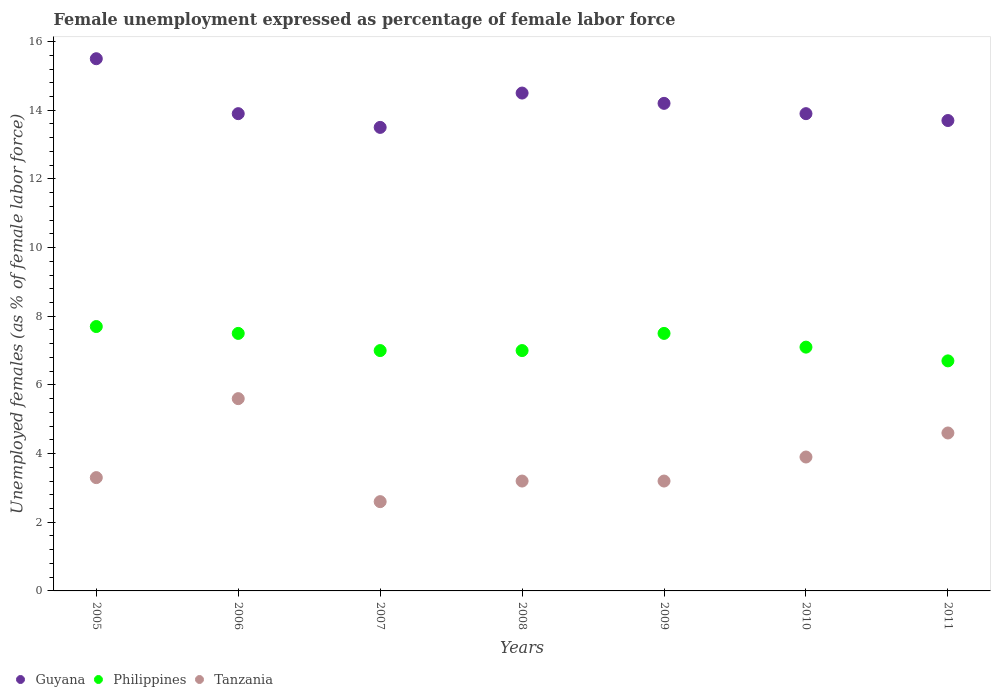How many different coloured dotlines are there?
Keep it short and to the point. 3. What is the unemployment in females in in Guyana in 2010?
Your response must be concise. 13.9. Across all years, what is the maximum unemployment in females in in Guyana?
Your answer should be very brief. 15.5. Across all years, what is the minimum unemployment in females in in Philippines?
Provide a short and direct response. 6.7. In which year was the unemployment in females in in Philippines maximum?
Your answer should be compact. 2005. In which year was the unemployment in females in in Tanzania minimum?
Provide a succinct answer. 2007. What is the total unemployment in females in in Guyana in the graph?
Your response must be concise. 99.2. What is the difference between the unemployment in females in in Guyana in 2009 and that in 2011?
Offer a very short reply. 0.5. What is the difference between the unemployment in females in in Tanzania in 2006 and the unemployment in females in in Philippines in 2008?
Your answer should be compact. -1.4. What is the average unemployment in females in in Philippines per year?
Keep it short and to the point. 7.21. In the year 2008, what is the difference between the unemployment in females in in Philippines and unemployment in females in in Guyana?
Provide a succinct answer. -7.5. In how many years, is the unemployment in females in in Guyana greater than 8 %?
Ensure brevity in your answer.  7. What is the ratio of the unemployment in females in in Guyana in 2008 to that in 2011?
Make the answer very short. 1.06. Is the unemployment in females in in Tanzania in 2005 less than that in 2007?
Provide a short and direct response. No. Is the difference between the unemployment in females in in Philippines in 2005 and 2009 greater than the difference between the unemployment in females in in Guyana in 2005 and 2009?
Your answer should be very brief. No. What is the difference between the highest and the second highest unemployment in females in in Tanzania?
Offer a terse response. 1. What is the difference between the highest and the lowest unemployment in females in in Philippines?
Provide a short and direct response. 1. Is it the case that in every year, the sum of the unemployment in females in in Tanzania and unemployment in females in in Philippines  is greater than the unemployment in females in in Guyana?
Make the answer very short. No. Is the unemployment in females in in Guyana strictly greater than the unemployment in females in in Philippines over the years?
Offer a terse response. Yes. Is the unemployment in females in in Philippines strictly less than the unemployment in females in in Guyana over the years?
Offer a very short reply. Yes. How many dotlines are there?
Offer a terse response. 3. How many years are there in the graph?
Your response must be concise. 7. How many legend labels are there?
Ensure brevity in your answer.  3. How are the legend labels stacked?
Offer a terse response. Horizontal. What is the title of the graph?
Your answer should be very brief. Female unemployment expressed as percentage of female labor force. Does "Madagascar" appear as one of the legend labels in the graph?
Offer a terse response. No. What is the label or title of the X-axis?
Provide a succinct answer. Years. What is the label or title of the Y-axis?
Keep it short and to the point. Unemployed females (as % of female labor force). What is the Unemployed females (as % of female labor force) in Philippines in 2005?
Keep it short and to the point. 7.7. What is the Unemployed females (as % of female labor force) in Tanzania in 2005?
Provide a succinct answer. 3.3. What is the Unemployed females (as % of female labor force) in Guyana in 2006?
Provide a succinct answer. 13.9. What is the Unemployed females (as % of female labor force) in Philippines in 2006?
Your response must be concise. 7.5. What is the Unemployed females (as % of female labor force) in Tanzania in 2006?
Keep it short and to the point. 5.6. What is the Unemployed females (as % of female labor force) of Guyana in 2007?
Provide a succinct answer. 13.5. What is the Unemployed females (as % of female labor force) of Tanzania in 2007?
Give a very brief answer. 2.6. What is the Unemployed females (as % of female labor force) in Philippines in 2008?
Keep it short and to the point. 7. What is the Unemployed females (as % of female labor force) of Tanzania in 2008?
Your response must be concise. 3.2. What is the Unemployed females (as % of female labor force) of Guyana in 2009?
Your response must be concise. 14.2. What is the Unemployed females (as % of female labor force) in Tanzania in 2009?
Give a very brief answer. 3.2. What is the Unemployed females (as % of female labor force) in Guyana in 2010?
Offer a terse response. 13.9. What is the Unemployed females (as % of female labor force) of Philippines in 2010?
Make the answer very short. 7.1. What is the Unemployed females (as % of female labor force) in Tanzania in 2010?
Offer a very short reply. 3.9. What is the Unemployed females (as % of female labor force) of Guyana in 2011?
Your answer should be compact. 13.7. What is the Unemployed females (as % of female labor force) of Philippines in 2011?
Offer a very short reply. 6.7. What is the Unemployed females (as % of female labor force) of Tanzania in 2011?
Keep it short and to the point. 4.6. Across all years, what is the maximum Unemployed females (as % of female labor force) of Guyana?
Give a very brief answer. 15.5. Across all years, what is the maximum Unemployed females (as % of female labor force) in Philippines?
Make the answer very short. 7.7. Across all years, what is the maximum Unemployed females (as % of female labor force) in Tanzania?
Your answer should be compact. 5.6. Across all years, what is the minimum Unemployed females (as % of female labor force) in Guyana?
Your response must be concise. 13.5. Across all years, what is the minimum Unemployed females (as % of female labor force) of Philippines?
Make the answer very short. 6.7. Across all years, what is the minimum Unemployed females (as % of female labor force) of Tanzania?
Ensure brevity in your answer.  2.6. What is the total Unemployed females (as % of female labor force) of Guyana in the graph?
Give a very brief answer. 99.2. What is the total Unemployed females (as % of female labor force) of Philippines in the graph?
Ensure brevity in your answer.  50.5. What is the total Unemployed females (as % of female labor force) in Tanzania in the graph?
Your answer should be very brief. 26.4. What is the difference between the Unemployed females (as % of female labor force) of Guyana in 2005 and that in 2006?
Provide a short and direct response. 1.6. What is the difference between the Unemployed females (as % of female labor force) of Philippines in 2005 and that in 2007?
Make the answer very short. 0.7. What is the difference between the Unemployed females (as % of female labor force) of Tanzania in 2005 and that in 2008?
Offer a terse response. 0.1. What is the difference between the Unemployed females (as % of female labor force) of Philippines in 2005 and that in 2009?
Provide a succinct answer. 0.2. What is the difference between the Unemployed females (as % of female labor force) in Guyana in 2005 and that in 2010?
Provide a succinct answer. 1.6. What is the difference between the Unemployed females (as % of female labor force) of Tanzania in 2005 and that in 2010?
Offer a very short reply. -0.6. What is the difference between the Unemployed females (as % of female labor force) in Guyana in 2005 and that in 2011?
Ensure brevity in your answer.  1.8. What is the difference between the Unemployed females (as % of female labor force) in Philippines in 2005 and that in 2011?
Your answer should be very brief. 1. What is the difference between the Unemployed females (as % of female labor force) of Tanzania in 2005 and that in 2011?
Your answer should be compact. -1.3. What is the difference between the Unemployed females (as % of female labor force) of Guyana in 2006 and that in 2007?
Your answer should be very brief. 0.4. What is the difference between the Unemployed females (as % of female labor force) of Philippines in 2006 and that in 2007?
Your answer should be compact. 0.5. What is the difference between the Unemployed females (as % of female labor force) of Philippines in 2006 and that in 2008?
Ensure brevity in your answer.  0.5. What is the difference between the Unemployed females (as % of female labor force) of Guyana in 2006 and that in 2009?
Your answer should be compact. -0.3. What is the difference between the Unemployed females (as % of female labor force) of Philippines in 2006 and that in 2009?
Your answer should be compact. 0. What is the difference between the Unemployed females (as % of female labor force) in Guyana in 2006 and that in 2010?
Give a very brief answer. 0. What is the difference between the Unemployed females (as % of female labor force) of Philippines in 2006 and that in 2010?
Give a very brief answer. 0.4. What is the difference between the Unemployed females (as % of female labor force) in Guyana in 2006 and that in 2011?
Your response must be concise. 0.2. What is the difference between the Unemployed females (as % of female labor force) in Philippines in 2006 and that in 2011?
Provide a short and direct response. 0.8. What is the difference between the Unemployed females (as % of female labor force) in Guyana in 2007 and that in 2008?
Your answer should be very brief. -1. What is the difference between the Unemployed females (as % of female labor force) of Tanzania in 2007 and that in 2008?
Your answer should be very brief. -0.6. What is the difference between the Unemployed females (as % of female labor force) of Philippines in 2007 and that in 2009?
Keep it short and to the point. -0.5. What is the difference between the Unemployed females (as % of female labor force) of Guyana in 2007 and that in 2010?
Your response must be concise. -0.4. What is the difference between the Unemployed females (as % of female labor force) of Tanzania in 2007 and that in 2010?
Your answer should be compact. -1.3. What is the difference between the Unemployed females (as % of female labor force) in Philippines in 2007 and that in 2011?
Make the answer very short. 0.3. What is the difference between the Unemployed females (as % of female labor force) in Tanzania in 2007 and that in 2011?
Keep it short and to the point. -2. What is the difference between the Unemployed females (as % of female labor force) in Guyana in 2008 and that in 2009?
Ensure brevity in your answer.  0.3. What is the difference between the Unemployed females (as % of female labor force) in Philippines in 2008 and that in 2009?
Provide a succinct answer. -0.5. What is the difference between the Unemployed females (as % of female labor force) in Tanzania in 2008 and that in 2009?
Your answer should be compact. 0. What is the difference between the Unemployed females (as % of female labor force) of Guyana in 2008 and that in 2010?
Make the answer very short. 0.6. What is the difference between the Unemployed females (as % of female labor force) in Philippines in 2008 and that in 2010?
Your answer should be very brief. -0.1. What is the difference between the Unemployed females (as % of female labor force) in Tanzania in 2008 and that in 2010?
Make the answer very short. -0.7. What is the difference between the Unemployed females (as % of female labor force) of Guyana in 2008 and that in 2011?
Offer a terse response. 0.8. What is the difference between the Unemployed females (as % of female labor force) in Philippines in 2009 and that in 2010?
Give a very brief answer. 0.4. What is the difference between the Unemployed females (as % of female labor force) of Philippines in 2009 and that in 2011?
Your response must be concise. 0.8. What is the difference between the Unemployed females (as % of female labor force) of Tanzania in 2009 and that in 2011?
Offer a very short reply. -1.4. What is the difference between the Unemployed females (as % of female labor force) of Guyana in 2010 and that in 2011?
Offer a very short reply. 0.2. What is the difference between the Unemployed females (as % of female labor force) of Tanzania in 2010 and that in 2011?
Make the answer very short. -0.7. What is the difference between the Unemployed females (as % of female labor force) in Philippines in 2005 and the Unemployed females (as % of female labor force) in Tanzania in 2006?
Provide a short and direct response. 2.1. What is the difference between the Unemployed females (as % of female labor force) in Guyana in 2005 and the Unemployed females (as % of female labor force) in Philippines in 2007?
Your answer should be very brief. 8.5. What is the difference between the Unemployed females (as % of female labor force) of Guyana in 2005 and the Unemployed females (as % of female labor force) of Tanzania in 2007?
Offer a very short reply. 12.9. What is the difference between the Unemployed females (as % of female labor force) of Philippines in 2005 and the Unemployed females (as % of female labor force) of Tanzania in 2007?
Your response must be concise. 5.1. What is the difference between the Unemployed females (as % of female labor force) of Guyana in 2005 and the Unemployed females (as % of female labor force) of Philippines in 2008?
Keep it short and to the point. 8.5. What is the difference between the Unemployed females (as % of female labor force) in Guyana in 2005 and the Unemployed females (as % of female labor force) in Philippines in 2009?
Give a very brief answer. 8. What is the difference between the Unemployed females (as % of female labor force) in Guyana in 2005 and the Unemployed females (as % of female labor force) in Tanzania in 2009?
Your answer should be very brief. 12.3. What is the difference between the Unemployed females (as % of female labor force) in Philippines in 2005 and the Unemployed females (as % of female labor force) in Tanzania in 2009?
Offer a terse response. 4.5. What is the difference between the Unemployed females (as % of female labor force) in Guyana in 2005 and the Unemployed females (as % of female labor force) in Philippines in 2010?
Provide a short and direct response. 8.4. What is the difference between the Unemployed females (as % of female labor force) in Guyana in 2006 and the Unemployed females (as % of female labor force) in Philippines in 2007?
Offer a terse response. 6.9. What is the difference between the Unemployed females (as % of female labor force) in Guyana in 2006 and the Unemployed females (as % of female labor force) in Tanzania in 2007?
Make the answer very short. 11.3. What is the difference between the Unemployed females (as % of female labor force) in Guyana in 2006 and the Unemployed females (as % of female labor force) in Tanzania in 2008?
Your answer should be compact. 10.7. What is the difference between the Unemployed females (as % of female labor force) in Philippines in 2006 and the Unemployed females (as % of female labor force) in Tanzania in 2008?
Your answer should be very brief. 4.3. What is the difference between the Unemployed females (as % of female labor force) of Guyana in 2006 and the Unemployed females (as % of female labor force) of Philippines in 2009?
Ensure brevity in your answer.  6.4. What is the difference between the Unemployed females (as % of female labor force) of Guyana in 2006 and the Unemployed females (as % of female labor force) of Tanzania in 2009?
Give a very brief answer. 10.7. What is the difference between the Unemployed females (as % of female labor force) of Guyana in 2006 and the Unemployed females (as % of female labor force) of Philippines in 2010?
Your answer should be compact. 6.8. What is the difference between the Unemployed females (as % of female labor force) in Guyana in 2006 and the Unemployed females (as % of female labor force) in Tanzania in 2010?
Make the answer very short. 10. What is the difference between the Unemployed females (as % of female labor force) of Philippines in 2006 and the Unemployed females (as % of female labor force) of Tanzania in 2010?
Offer a very short reply. 3.6. What is the difference between the Unemployed females (as % of female labor force) in Guyana in 2006 and the Unemployed females (as % of female labor force) in Tanzania in 2011?
Ensure brevity in your answer.  9.3. What is the difference between the Unemployed females (as % of female labor force) in Guyana in 2007 and the Unemployed females (as % of female labor force) in Philippines in 2008?
Provide a succinct answer. 6.5. What is the difference between the Unemployed females (as % of female labor force) in Guyana in 2007 and the Unemployed females (as % of female labor force) in Tanzania in 2008?
Ensure brevity in your answer.  10.3. What is the difference between the Unemployed females (as % of female labor force) of Philippines in 2007 and the Unemployed females (as % of female labor force) of Tanzania in 2008?
Make the answer very short. 3.8. What is the difference between the Unemployed females (as % of female labor force) in Guyana in 2007 and the Unemployed females (as % of female labor force) in Tanzania in 2009?
Provide a succinct answer. 10.3. What is the difference between the Unemployed females (as % of female labor force) in Philippines in 2007 and the Unemployed females (as % of female labor force) in Tanzania in 2009?
Provide a succinct answer. 3.8. What is the difference between the Unemployed females (as % of female labor force) of Guyana in 2007 and the Unemployed females (as % of female labor force) of Tanzania in 2011?
Your answer should be very brief. 8.9. What is the difference between the Unemployed females (as % of female labor force) of Guyana in 2008 and the Unemployed females (as % of female labor force) of Tanzania in 2009?
Keep it short and to the point. 11.3. What is the difference between the Unemployed females (as % of female labor force) in Philippines in 2008 and the Unemployed females (as % of female labor force) in Tanzania in 2009?
Offer a very short reply. 3.8. What is the difference between the Unemployed females (as % of female labor force) in Philippines in 2008 and the Unemployed females (as % of female labor force) in Tanzania in 2010?
Give a very brief answer. 3.1. What is the difference between the Unemployed females (as % of female labor force) in Philippines in 2008 and the Unemployed females (as % of female labor force) in Tanzania in 2011?
Give a very brief answer. 2.4. What is the difference between the Unemployed females (as % of female labor force) of Guyana in 2009 and the Unemployed females (as % of female labor force) of Tanzania in 2010?
Offer a very short reply. 10.3. What is the difference between the Unemployed females (as % of female labor force) in Philippines in 2009 and the Unemployed females (as % of female labor force) in Tanzania in 2010?
Provide a short and direct response. 3.6. What is the difference between the Unemployed females (as % of female labor force) of Guyana in 2009 and the Unemployed females (as % of female labor force) of Philippines in 2011?
Give a very brief answer. 7.5. What is the difference between the Unemployed females (as % of female labor force) in Guyana in 2009 and the Unemployed females (as % of female labor force) in Tanzania in 2011?
Provide a short and direct response. 9.6. What is the difference between the Unemployed females (as % of female labor force) of Philippines in 2009 and the Unemployed females (as % of female labor force) of Tanzania in 2011?
Provide a succinct answer. 2.9. What is the average Unemployed females (as % of female labor force) in Guyana per year?
Make the answer very short. 14.17. What is the average Unemployed females (as % of female labor force) of Philippines per year?
Make the answer very short. 7.21. What is the average Unemployed females (as % of female labor force) in Tanzania per year?
Give a very brief answer. 3.77. In the year 2005, what is the difference between the Unemployed females (as % of female labor force) in Guyana and Unemployed females (as % of female labor force) in Philippines?
Your answer should be very brief. 7.8. In the year 2007, what is the difference between the Unemployed females (as % of female labor force) of Guyana and Unemployed females (as % of female labor force) of Philippines?
Provide a succinct answer. 6.5. In the year 2008, what is the difference between the Unemployed females (as % of female labor force) of Guyana and Unemployed females (as % of female labor force) of Philippines?
Provide a succinct answer. 7.5. In the year 2008, what is the difference between the Unemployed females (as % of female labor force) of Guyana and Unemployed females (as % of female labor force) of Tanzania?
Give a very brief answer. 11.3. In the year 2008, what is the difference between the Unemployed females (as % of female labor force) of Philippines and Unemployed females (as % of female labor force) of Tanzania?
Your answer should be compact. 3.8. In the year 2009, what is the difference between the Unemployed females (as % of female labor force) in Guyana and Unemployed females (as % of female labor force) in Tanzania?
Provide a short and direct response. 11. In the year 2010, what is the difference between the Unemployed females (as % of female labor force) in Guyana and Unemployed females (as % of female labor force) in Tanzania?
Keep it short and to the point. 10. In the year 2010, what is the difference between the Unemployed females (as % of female labor force) of Philippines and Unemployed females (as % of female labor force) of Tanzania?
Keep it short and to the point. 3.2. In the year 2011, what is the difference between the Unemployed females (as % of female labor force) in Guyana and Unemployed females (as % of female labor force) in Philippines?
Your answer should be compact. 7. What is the ratio of the Unemployed females (as % of female labor force) of Guyana in 2005 to that in 2006?
Offer a terse response. 1.12. What is the ratio of the Unemployed females (as % of female labor force) of Philippines in 2005 to that in 2006?
Your answer should be compact. 1.03. What is the ratio of the Unemployed females (as % of female labor force) in Tanzania in 2005 to that in 2006?
Keep it short and to the point. 0.59. What is the ratio of the Unemployed females (as % of female labor force) in Guyana in 2005 to that in 2007?
Provide a succinct answer. 1.15. What is the ratio of the Unemployed females (as % of female labor force) in Tanzania in 2005 to that in 2007?
Provide a succinct answer. 1.27. What is the ratio of the Unemployed females (as % of female labor force) in Guyana in 2005 to that in 2008?
Give a very brief answer. 1.07. What is the ratio of the Unemployed females (as % of female labor force) in Philippines in 2005 to that in 2008?
Provide a succinct answer. 1.1. What is the ratio of the Unemployed females (as % of female labor force) of Tanzania in 2005 to that in 2008?
Provide a succinct answer. 1.03. What is the ratio of the Unemployed females (as % of female labor force) in Guyana in 2005 to that in 2009?
Offer a very short reply. 1.09. What is the ratio of the Unemployed females (as % of female labor force) in Philippines in 2005 to that in 2009?
Your answer should be compact. 1.03. What is the ratio of the Unemployed females (as % of female labor force) of Tanzania in 2005 to that in 2009?
Your response must be concise. 1.03. What is the ratio of the Unemployed females (as % of female labor force) in Guyana in 2005 to that in 2010?
Give a very brief answer. 1.12. What is the ratio of the Unemployed females (as % of female labor force) in Philippines in 2005 to that in 2010?
Provide a succinct answer. 1.08. What is the ratio of the Unemployed females (as % of female labor force) in Tanzania in 2005 to that in 2010?
Your answer should be compact. 0.85. What is the ratio of the Unemployed females (as % of female labor force) of Guyana in 2005 to that in 2011?
Your answer should be very brief. 1.13. What is the ratio of the Unemployed females (as % of female labor force) of Philippines in 2005 to that in 2011?
Ensure brevity in your answer.  1.15. What is the ratio of the Unemployed females (as % of female labor force) in Tanzania in 2005 to that in 2011?
Give a very brief answer. 0.72. What is the ratio of the Unemployed females (as % of female labor force) in Guyana in 2006 to that in 2007?
Give a very brief answer. 1.03. What is the ratio of the Unemployed females (as % of female labor force) of Philippines in 2006 to that in 2007?
Offer a very short reply. 1.07. What is the ratio of the Unemployed females (as % of female labor force) of Tanzania in 2006 to that in 2007?
Keep it short and to the point. 2.15. What is the ratio of the Unemployed females (as % of female labor force) of Guyana in 2006 to that in 2008?
Your answer should be compact. 0.96. What is the ratio of the Unemployed females (as % of female labor force) in Philippines in 2006 to that in 2008?
Offer a very short reply. 1.07. What is the ratio of the Unemployed females (as % of female labor force) in Guyana in 2006 to that in 2009?
Provide a succinct answer. 0.98. What is the ratio of the Unemployed females (as % of female labor force) of Philippines in 2006 to that in 2009?
Keep it short and to the point. 1. What is the ratio of the Unemployed females (as % of female labor force) in Philippines in 2006 to that in 2010?
Provide a short and direct response. 1.06. What is the ratio of the Unemployed females (as % of female labor force) in Tanzania in 2006 to that in 2010?
Provide a succinct answer. 1.44. What is the ratio of the Unemployed females (as % of female labor force) in Guyana in 2006 to that in 2011?
Offer a terse response. 1.01. What is the ratio of the Unemployed females (as % of female labor force) in Philippines in 2006 to that in 2011?
Your answer should be compact. 1.12. What is the ratio of the Unemployed females (as % of female labor force) of Tanzania in 2006 to that in 2011?
Ensure brevity in your answer.  1.22. What is the ratio of the Unemployed females (as % of female labor force) in Tanzania in 2007 to that in 2008?
Keep it short and to the point. 0.81. What is the ratio of the Unemployed females (as % of female labor force) in Guyana in 2007 to that in 2009?
Offer a terse response. 0.95. What is the ratio of the Unemployed females (as % of female labor force) in Tanzania in 2007 to that in 2009?
Provide a succinct answer. 0.81. What is the ratio of the Unemployed females (as % of female labor force) in Guyana in 2007 to that in 2010?
Make the answer very short. 0.97. What is the ratio of the Unemployed females (as % of female labor force) of Philippines in 2007 to that in 2010?
Offer a terse response. 0.99. What is the ratio of the Unemployed females (as % of female labor force) in Guyana in 2007 to that in 2011?
Provide a succinct answer. 0.99. What is the ratio of the Unemployed females (as % of female labor force) of Philippines in 2007 to that in 2011?
Your answer should be very brief. 1.04. What is the ratio of the Unemployed females (as % of female labor force) in Tanzania in 2007 to that in 2011?
Ensure brevity in your answer.  0.57. What is the ratio of the Unemployed females (as % of female labor force) in Guyana in 2008 to that in 2009?
Provide a short and direct response. 1.02. What is the ratio of the Unemployed females (as % of female labor force) of Tanzania in 2008 to that in 2009?
Your response must be concise. 1. What is the ratio of the Unemployed females (as % of female labor force) in Guyana in 2008 to that in 2010?
Your response must be concise. 1.04. What is the ratio of the Unemployed females (as % of female labor force) in Philippines in 2008 to that in 2010?
Your response must be concise. 0.99. What is the ratio of the Unemployed females (as % of female labor force) of Tanzania in 2008 to that in 2010?
Give a very brief answer. 0.82. What is the ratio of the Unemployed females (as % of female labor force) of Guyana in 2008 to that in 2011?
Make the answer very short. 1.06. What is the ratio of the Unemployed females (as % of female labor force) in Philippines in 2008 to that in 2011?
Your response must be concise. 1.04. What is the ratio of the Unemployed females (as % of female labor force) of Tanzania in 2008 to that in 2011?
Keep it short and to the point. 0.7. What is the ratio of the Unemployed females (as % of female labor force) in Guyana in 2009 to that in 2010?
Offer a very short reply. 1.02. What is the ratio of the Unemployed females (as % of female labor force) of Philippines in 2009 to that in 2010?
Make the answer very short. 1.06. What is the ratio of the Unemployed females (as % of female labor force) of Tanzania in 2009 to that in 2010?
Make the answer very short. 0.82. What is the ratio of the Unemployed females (as % of female labor force) of Guyana in 2009 to that in 2011?
Make the answer very short. 1.04. What is the ratio of the Unemployed females (as % of female labor force) in Philippines in 2009 to that in 2011?
Your answer should be very brief. 1.12. What is the ratio of the Unemployed females (as % of female labor force) of Tanzania in 2009 to that in 2011?
Provide a short and direct response. 0.7. What is the ratio of the Unemployed females (as % of female labor force) of Guyana in 2010 to that in 2011?
Ensure brevity in your answer.  1.01. What is the ratio of the Unemployed females (as % of female labor force) of Philippines in 2010 to that in 2011?
Offer a terse response. 1.06. What is the ratio of the Unemployed females (as % of female labor force) of Tanzania in 2010 to that in 2011?
Ensure brevity in your answer.  0.85. What is the difference between the highest and the lowest Unemployed females (as % of female labor force) in Guyana?
Your answer should be compact. 2. What is the difference between the highest and the lowest Unemployed females (as % of female labor force) of Philippines?
Keep it short and to the point. 1. What is the difference between the highest and the lowest Unemployed females (as % of female labor force) in Tanzania?
Your response must be concise. 3. 